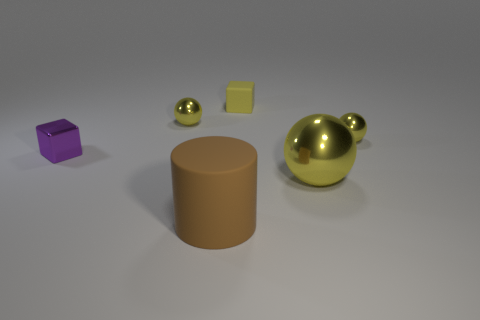What size is the matte object that is the same color as the large metallic sphere?
Ensure brevity in your answer.  Small. There is a matte thing that is behind the big brown matte object; does it have the same shape as the big brown rubber object?
Keep it short and to the point. No. What number of shiny objects are there?
Offer a very short reply. 4. How many other red shiny cylinders are the same size as the cylinder?
Provide a short and direct response. 0. What material is the big sphere?
Keep it short and to the point. Metal. There is a large cylinder; does it have the same color as the tiny ball to the left of the rubber block?
Give a very brief answer. No. Are there any other things that are the same size as the purple object?
Your answer should be compact. Yes. What is the size of the yellow thing that is left of the large yellow shiny sphere and in front of the yellow cube?
Give a very brief answer. Small. The small object that is made of the same material as the big brown cylinder is what shape?
Offer a terse response. Cube. Are the brown cylinder and the small purple cube to the left of the yellow rubber cube made of the same material?
Provide a short and direct response. No. 